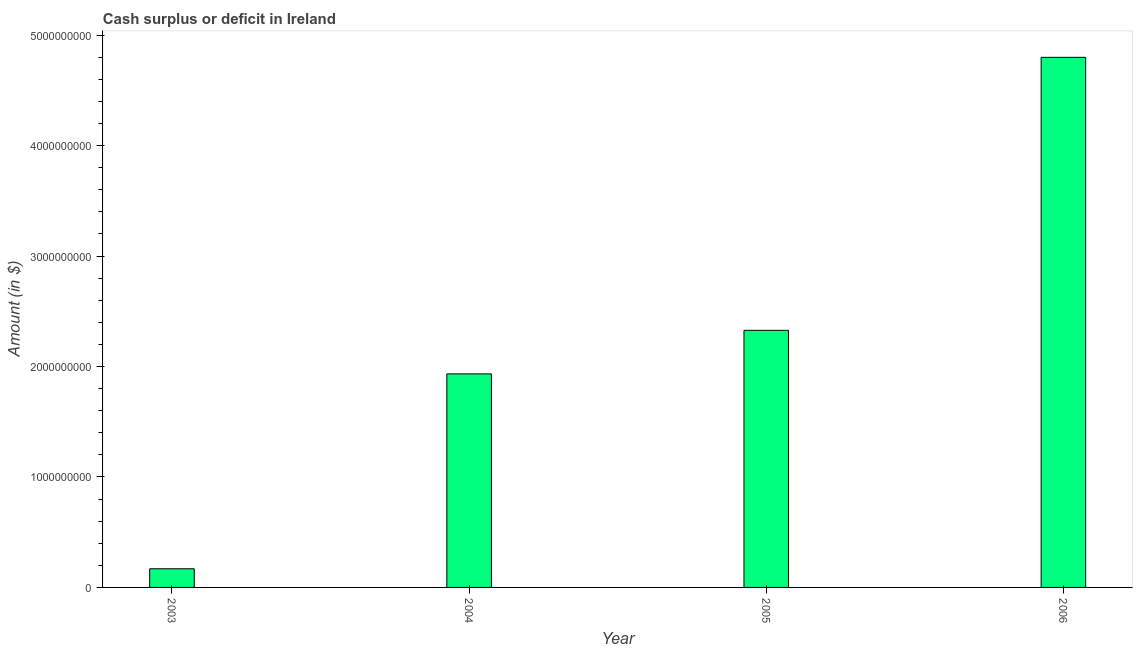What is the title of the graph?
Provide a succinct answer. Cash surplus or deficit in Ireland. What is the label or title of the X-axis?
Keep it short and to the point. Year. What is the label or title of the Y-axis?
Provide a short and direct response. Amount (in $). What is the cash surplus or deficit in 2003?
Ensure brevity in your answer.  1.69e+08. Across all years, what is the maximum cash surplus or deficit?
Your answer should be compact. 4.80e+09. Across all years, what is the minimum cash surplus or deficit?
Your answer should be very brief. 1.69e+08. In which year was the cash surplus or deficit maximum?
Give a very brief answer. 2006. What is the sum of the cash surplus or deficit?
Make the answer very short. 9.23e+09. What is the difference between the cash surplus or deficit in 2003 and 2005?
Provide a short and direct response. -2.16e+09. What is the average cash surplus or deficit per year?
Offer a terse response. 2.31e+09. What is the median cash surplus or deficit?
Your answer should be compact. 2.13e+09. In how many years, is the cash surplus or deficit greater than 4800000000 $?
Ensure brevity in your answer.  0. What is the ratio of the cash surplus or deficit in 2004 to that in 2006?
Offer a very short reply. 0.4. Is the difference between the cash surplus or deficit in 2004 and 2005 greater than the difference between any two years?
Your answer should be compact. No. What is the difference between the highest and the second highest cash surplus or deficit?
Offer a terse response. 2.47e+09. What is the difference between the highest and the lowest cash surplus or deficit?
Your answer should be very brief. 4.63e+09. How many bars are there?
Give a very brief answer. 4. How many years are there in the graph?
Ensure brevity in your answer.  4. Are the values on the major ticks of Y-axis written in scientific E-notation?
Provide a succinct answer. No. What is the Amount (in $) of 2003?
Keep it short and to the point. 1.69e+08. What is the Amount (in $) of 2004?
Ensure brevity in your answer.  1.93e+09. What is the Amount (in $) of 2005?
Your response must be concise. 2.33e+09. What is the Amount (in $) of 2006?
Ensure brevity in your answer.  4.80e+09. What is the difference between the Amount (in $) in 2003 and 2004?
Offer a terse response. -1.76e+09. What is the difference between the Amount (in $) in 2003 and 2005?
Your response must be concise. -2.16e+09. What is the difference between the Amount (in $) in 2003 and 2006?
Your response must be concise. -4.63e+09. What is the difference between the Amount (in $) in 2004 and 2005?
Give a very brief answer. -3.94e+08. What is the difference between the Amount (in $) in 2004 and 2006?
Make the answer very short. -2.87e+09. What is the difference between the Amount (in $) in 2005 and 2006?
Your answer should be compact. -2.47e+09. What is the ratio of the Amount (in $) in 2003 to that in 2004?
Ensure brevity in your answer.  0.09. What is the ratio of the Amount (in $) in 2003 to that in 2005?
Ensure brevity in your answer.  0.07. What is the ratio of the Amount (in $) in 2003 to that in 2006?
Offer a terse response. 0.04. What is the ratio of the Amount (in $) in 2004 to that in 2005?
Make the answer very short. 0.83. What is the ratio of the Amount (in $) in 2004 to that in 2006?
Make the answer very short. 0.4. What is the ratio of the Amount (in $) in 2005 to that in 2006?
Provide a succinct answer. 0.48. 